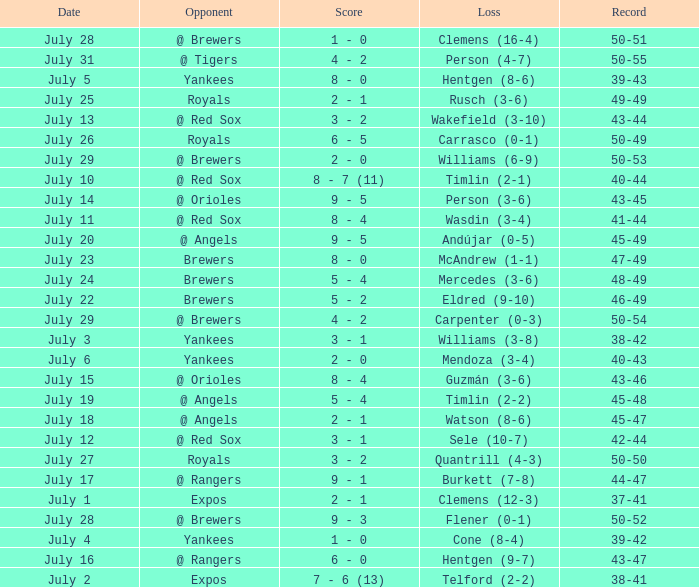What's the record on july 10? 40-44. 